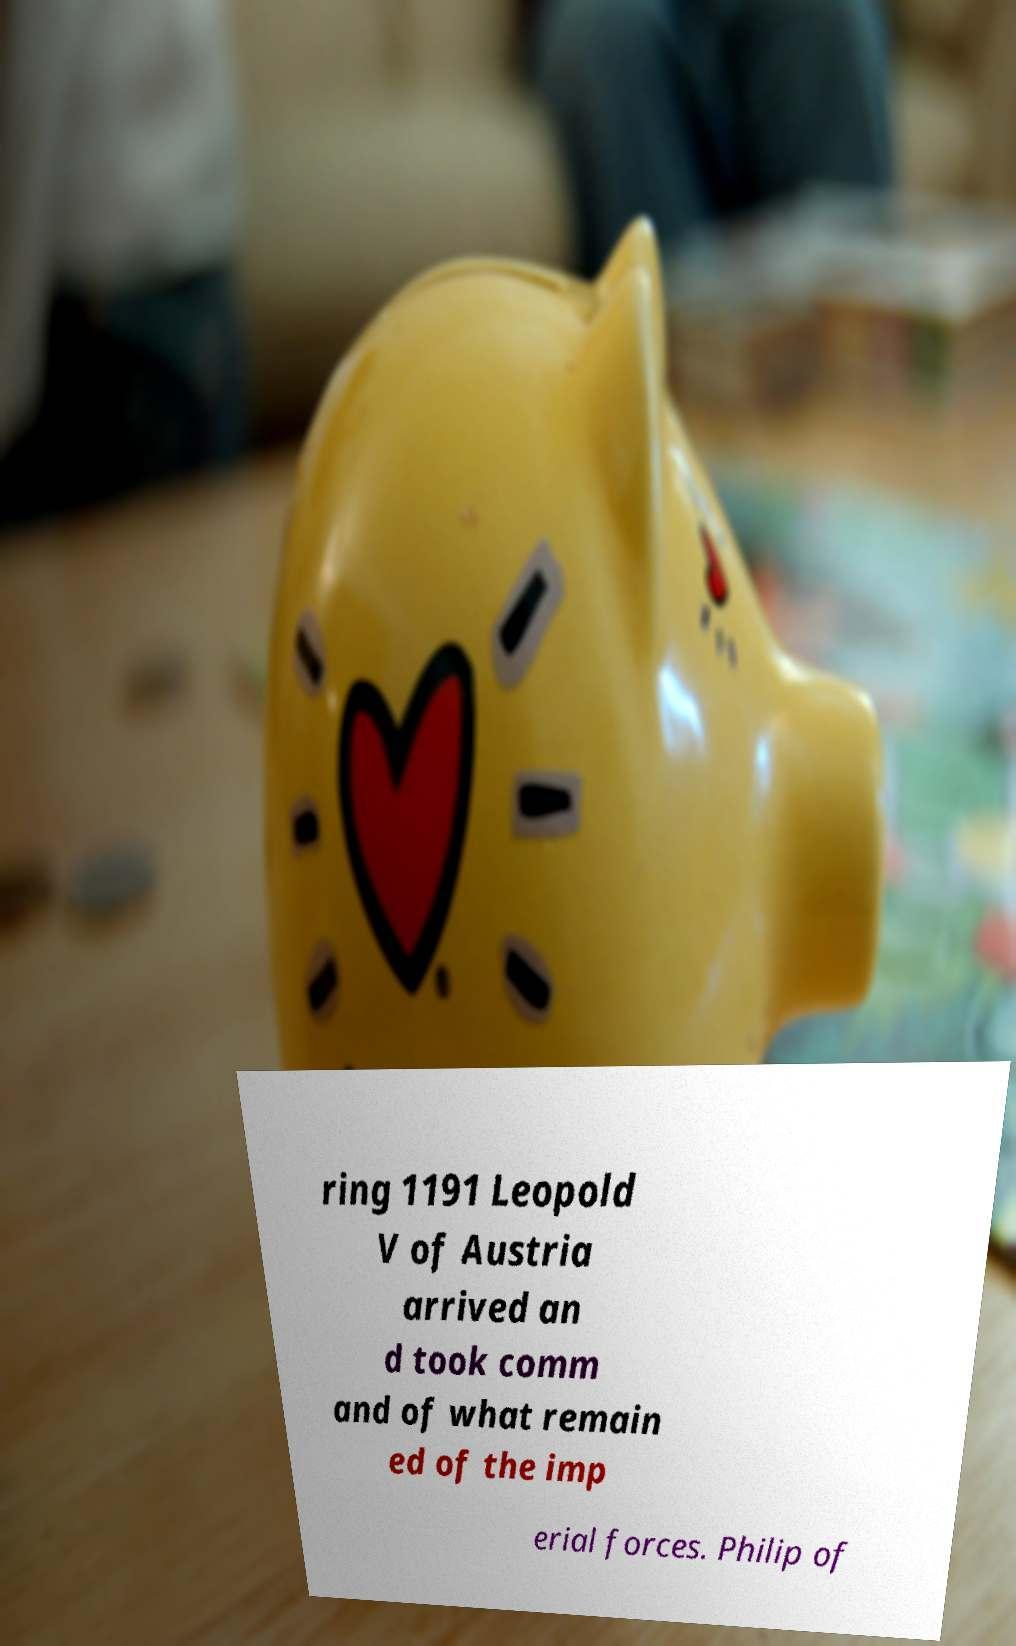Please identify and transcribe the text found in this image. ring 1191 Leopold V of Austria arrived an d took comm and of what remain ed of the imp erial forces. Philip of 